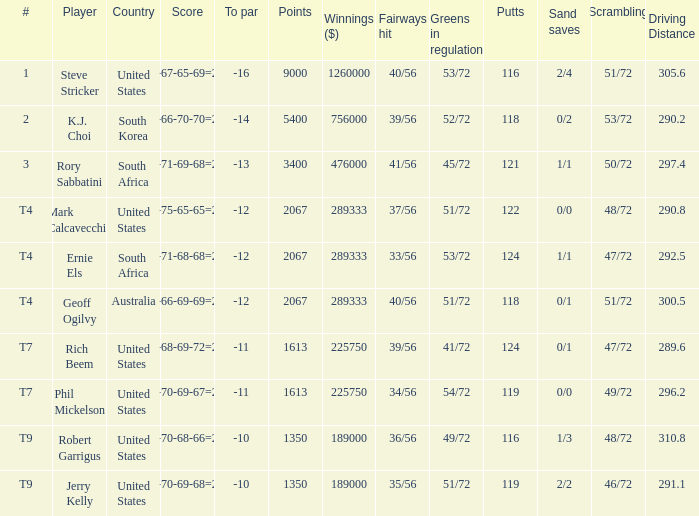Name the number of points for south korea 1.0. 